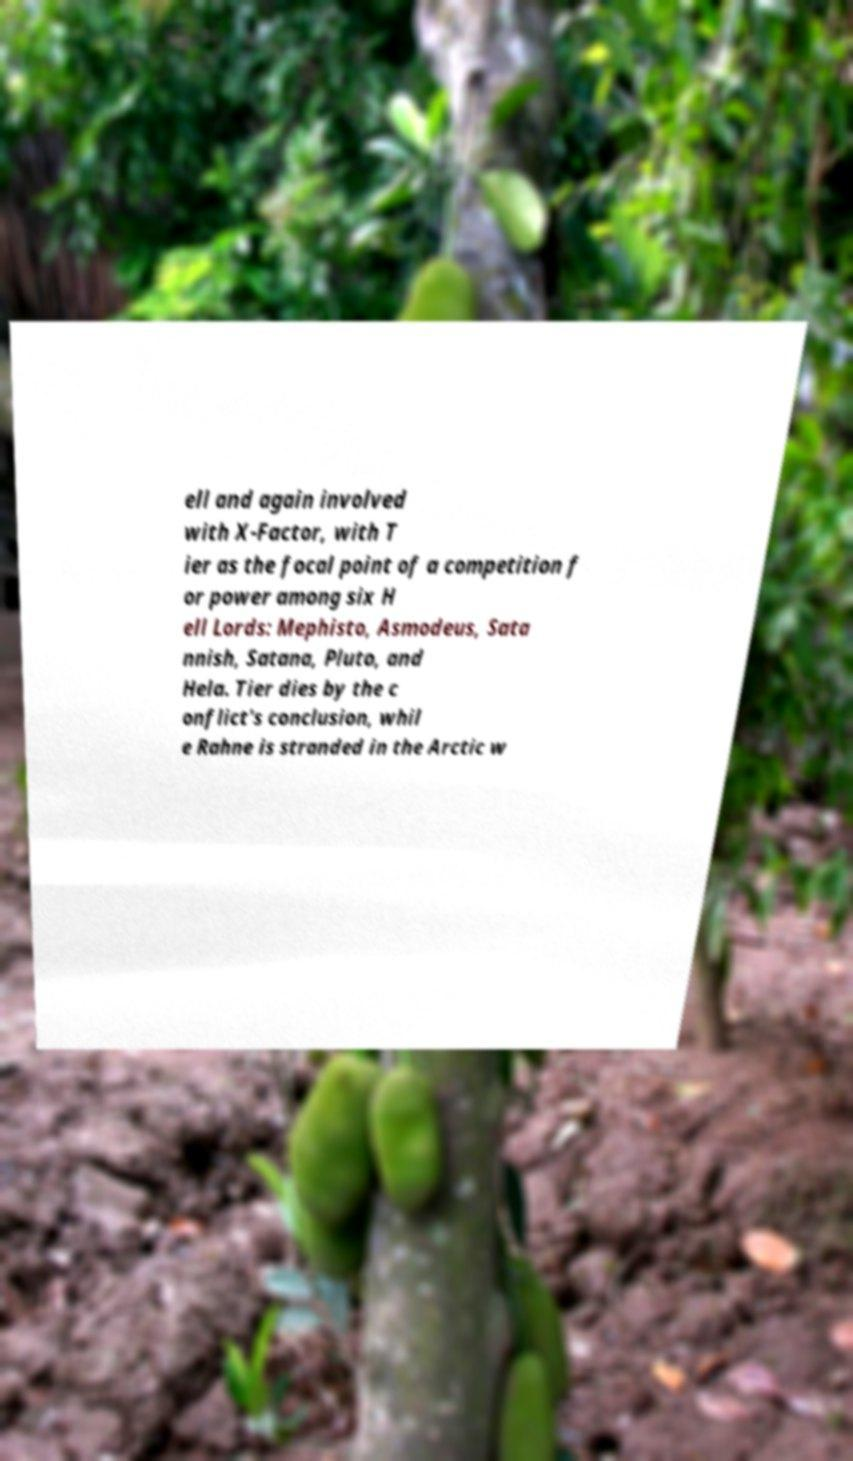Could you extract and type out the text from this image? ell and again involved with X-Factor, with T ier as the focal point of a competition f or power among six H ell Lords: Mephisto, Asmodeus, Sata nnish, Satana, Pluto, and Hela. Tier dies by the c onflict's conclusion, whil e Rahne is stranded in the Arctic w 